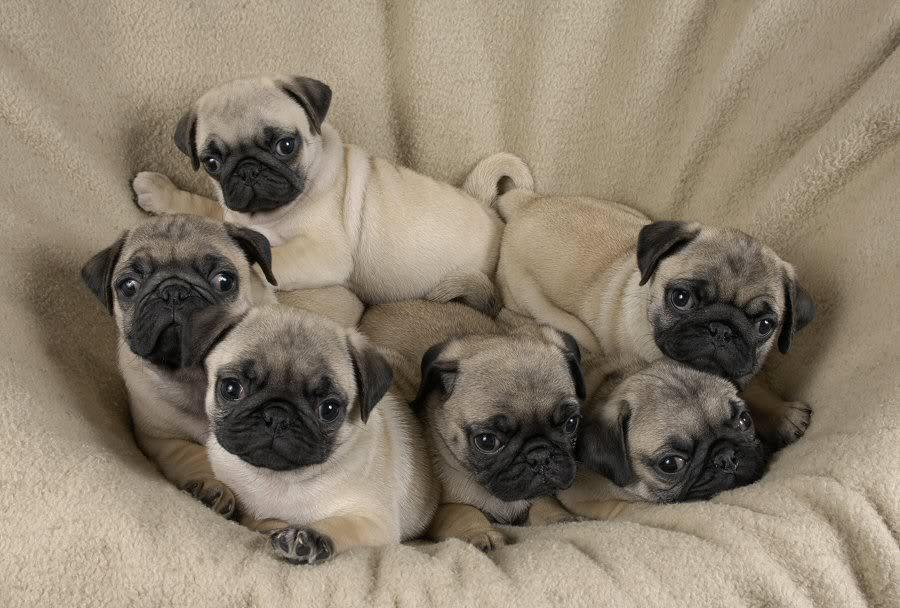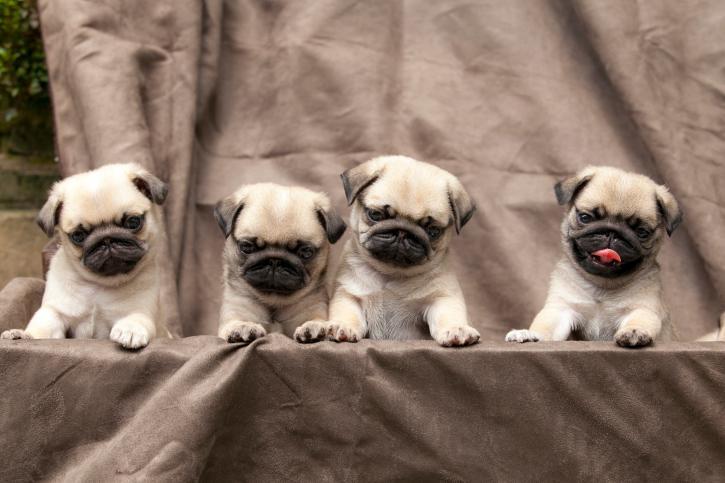The first image is the image on the left, the second image is the image on the right. Given the left and right images, does the statement "In one of the images, at least one of the dogs is entirely black." hold true? Answer yes or no. No. The first image is the image on the left, the second image is the image on the right. Considering the images on both sides, is "An image contains at least three pug dogs dressed in garments other than dog collars." valid? Answer yes or no. No. 